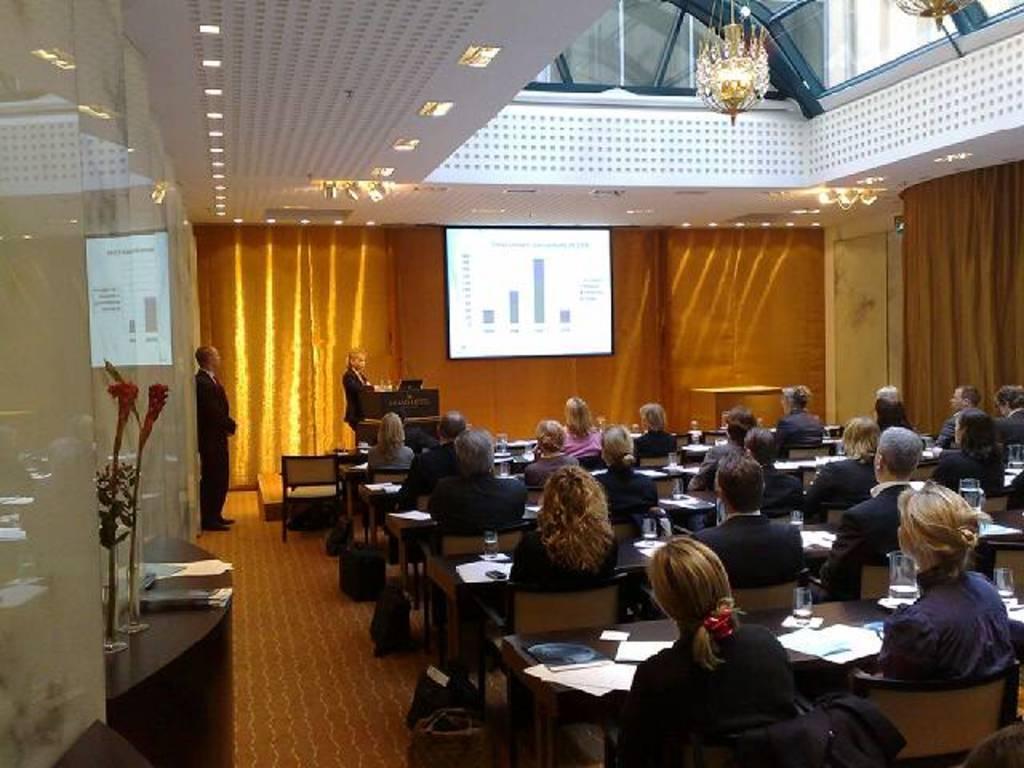Please provide a concise description of this image. In this image there are so many people sitting on chairs in-front of table where we can see there are some papers and glasses, also there is a projector screen and few people standing in-front of them and there is a chandelier hanging at the roof. 